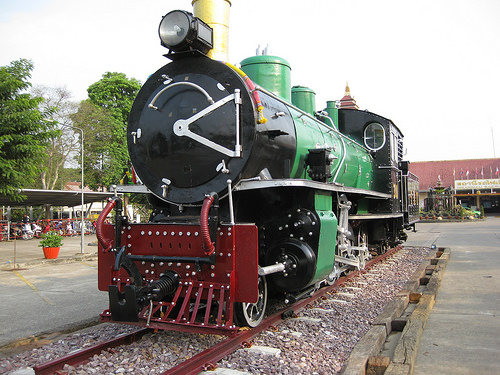<image>
Is the train on the track? Yes. Looking at the image, I can see the train is positioned on top of the track, with the track providing support. Is there a plant on the train? No. The plant is not positioned on the train. They may be near each other, but the plant is not supported by or resting on top of the train. 